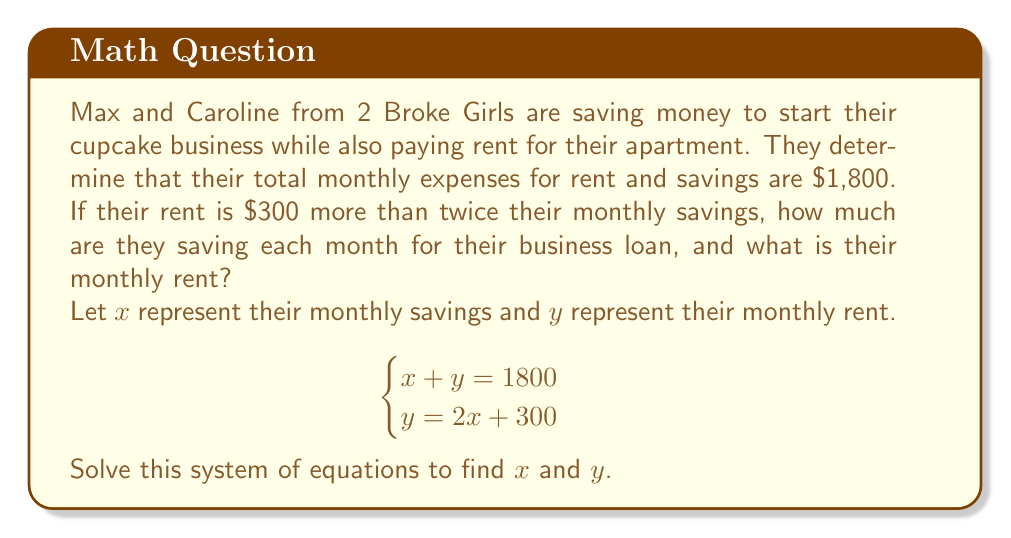Could you help me with this problem? Let's solve this system of equations step by step:

1) We have two equations:
   $$\begin{cases}
   x + y = 1800 \quad \text{(Equation 1)}\\
   y = 2x + 300 \quad \text{(Equation 2)}
   \end{cases}$$

2) Let's substitute Equation 2 into Equation 1:
   $$x + (2x + 300) = 1800$$

3) Simplify:
   $$x + 2x + 300 = 1800$$
   $$3x + 300 = 1800$$

4) Subtract 300 from both sides:
   $$3x = 1500$$

5) Divide both sides by 3:
   $$x = 500$$

6) Now that we know $x$, let's find $y$ using Equation 2:
   $$y = 2(500) + 300 = 1000 + 300 = 1300$$

Therefore, Max and Caroline are saving $500 per month for their business loan, and their monthly rent is $1,300.

We can verify this solution:
- Monthly savings ($x$) + Monthly rent ($y$) = $500 + $1,300 = $1,800 (satisfies Equation 1)
- Monthly rent ($y$) = 2 * Monthly savings ($x$) + $300 = 2($500) + $300 = $1,300 (satisfies Equation 2)
Answer: Monthly savings for business loan: $500
Monthly rent: $1,300 